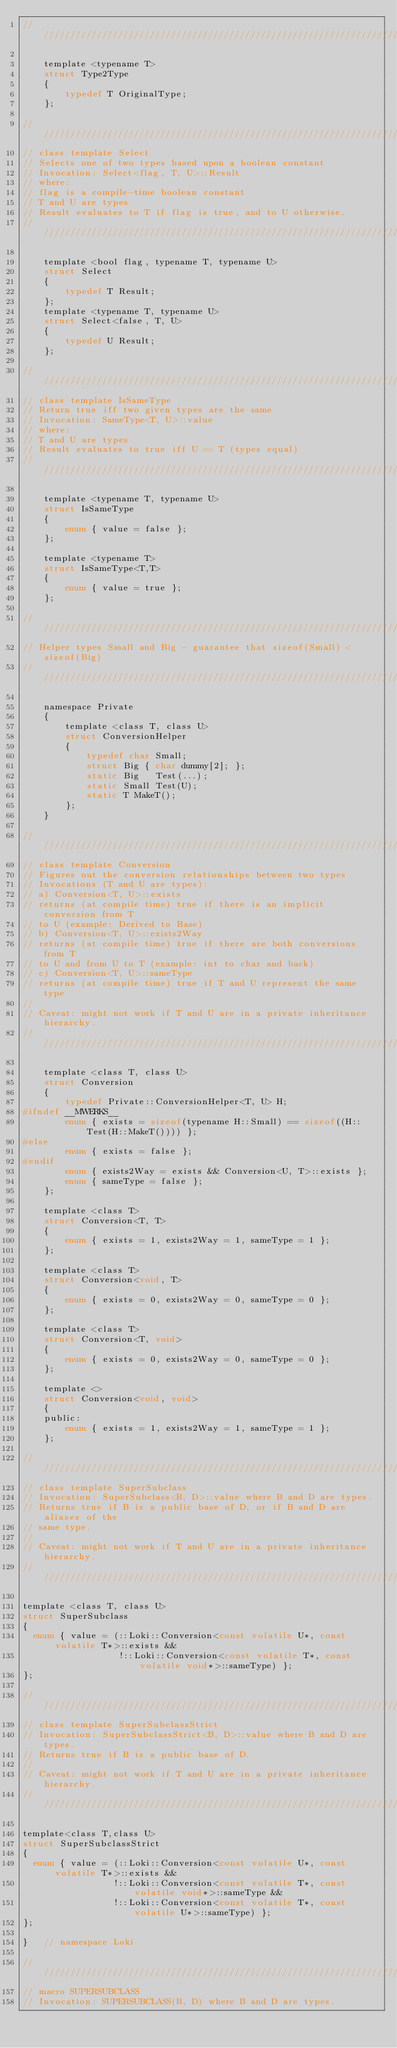<code> <loc_0><loc_0><loc_500><loc_500><_C_>////////////////////////////////////////////////////////////////////////////////

    template <typename T>
    struct Type2Type
    {
        typedef T OriginalType;
    };
    
////////////////////////////////////////////////////////////////////////////////
// class template Select
// Selects one of two types based upon a boolean constant
// Invocation: Select<flag, T, U>::Result
// where:
// flag is a compile-time boolean constant
// T and U are types
// Result evaluates to T if flag is true, and to U otherwise.
////////////////////////////////////////////////////////////////////////////////

    template <bool flag, typename T, typename U>
    struct Select
    {
        typedef T Result;
    };
    template <typename T, typename U>
    struct Select<false, T, U>
    {
        typedef U Result;
    };
    
////////////////////////////////////////////////////////////////////////////////
// class template IsSameType
// Return true iff two given types are the same
// Invocation: SameType<T, U>::value
// where:
// T and U are types
// Result evaluates to true iff U == T (types equal)
////////////////////////////////////////////////////////////////////////////////

    template <typename T, typename U>
    struct IsSameType
    {
        enum { value = false };
    };
    
    template <typename T>
    struct IsSameType<T,T>
    {
        enum { value = true };
    };

////////////////////////////////////////////////////////////////////////////////
// Helper types Small and Big - guarantee that sizeof(Small) < sizeof(Big)
////////////////////////////////////////////////////////////////////////////////

    namespace Private
    {
        template <class T, class U>
        struct ConversionHelper
        {
            typedef char Small;
            struct Big { char dummy[2]; };
            static Big   Test(...);
            static Small Test(U);
            static T MakeT();
        };
    }

////////////////////////////////////////////////////////////////////////////////
// class template Conversion
// Figures out the conversion relationships between two types
// Invocations (T and U are types):
// a) Conversion<T, U>::exists
// returns (at compile time) true if there is an implicit conversion from T
// to U (example: Derived to Base)
// b) Conversion<T, U>::exists2Way
// returns (at compile time) true if there are both conversions from T
// to U and from U to T (example: int to char and back)
// c) Conversion<T, U>::sameType
// returns (at compile time) true if T and U represent the same type
//
// Caveat: might not work if T and U are in a private inheritance hierarchy.
////////////////////////////////////////////////////////////////////////////////

    template <class T, class U>
    struct Conversion
    {
        typedef Private::ConversionHelper<T, U> H;
#ifndef __MWERKS__
        enum { exists = sizeof(typename H::Small) == sizeof((H::Test(H::MakeT()))) };
#else
        enum { exists = false };
#endif
        enum { exists2Way = exists && Conversion<U, T>::exists };
        enum { sameType = false };
    };
    
    template <class T>
    struct Conversion<T, T>    
    {
        enum { exists = 1, exists2Way = 1, sameType = 1 };
    };
    
    template <class T>
    struct Conversion<void, T>    
    {
        enum { exists = 0, exists2Way = 0, sameType = 0 };
    };
    
    template <class T>
    struct Conversion<T, void>    
    {
        enum { exists = 0, exists2Way = 0, sameType = 0 };
    };
    
    template <>
    struct Conversion<void, void>    
    {
    public:
        enum { exists = 1, exists2Way = 1, sameType = 1 };
    };

////////////////////////////////////////////////////////////////////////////////
// class template SuperSubclass
// Invocation: SuperSubclass<B, D>::value where B and D are types. 
// Returns true if B is a public base of D, or if B and D are aliases of the 
// same type.
//
// Caveat: might not work if T and U are in a private inheritance hierarchy.
////////////////////////////////////////////////////////////////////////////////

template <class T, class U>
struct SuperSubclass
{
  enum { value = (::Loki::Conversion<const volatile U*, const volatile T*>::exists &&
                  !::Loki::Conversion<const volatile T*, const volatile void*>::sameType) };
};

////////////////////////////////////////////////////////////////////////////////
// class template SuperSubclassStrict
// Invocation: SuperSubclassStrict<B, D>::value where B and D are types. 
// Returns true if B is a public base of D.
//
// Caveat: might not work if T and U are in a private inheritance hierarchy.
////////////////////////////////////////////////////////////////////////////////

template<class T,class U>
struct SuperSubclassStrict
{
  enum { value = (::Loki::Conversion<const volatile U*, const volatile T*>::exists &&
                 !::Loki::Conversion<const volatile T*, const volatile void*>::sameType &&
                 !::Loki::Conversion<const volatile T*, const volatile U*>::sameType) };
};

}   // namespace Loki

////////////////////////////////////////////////////////////////////////////////
// macro SUPERSUBCLASS
// Invocation: SUPERSUBCLASS(B, D) where B and D are types. </code> 